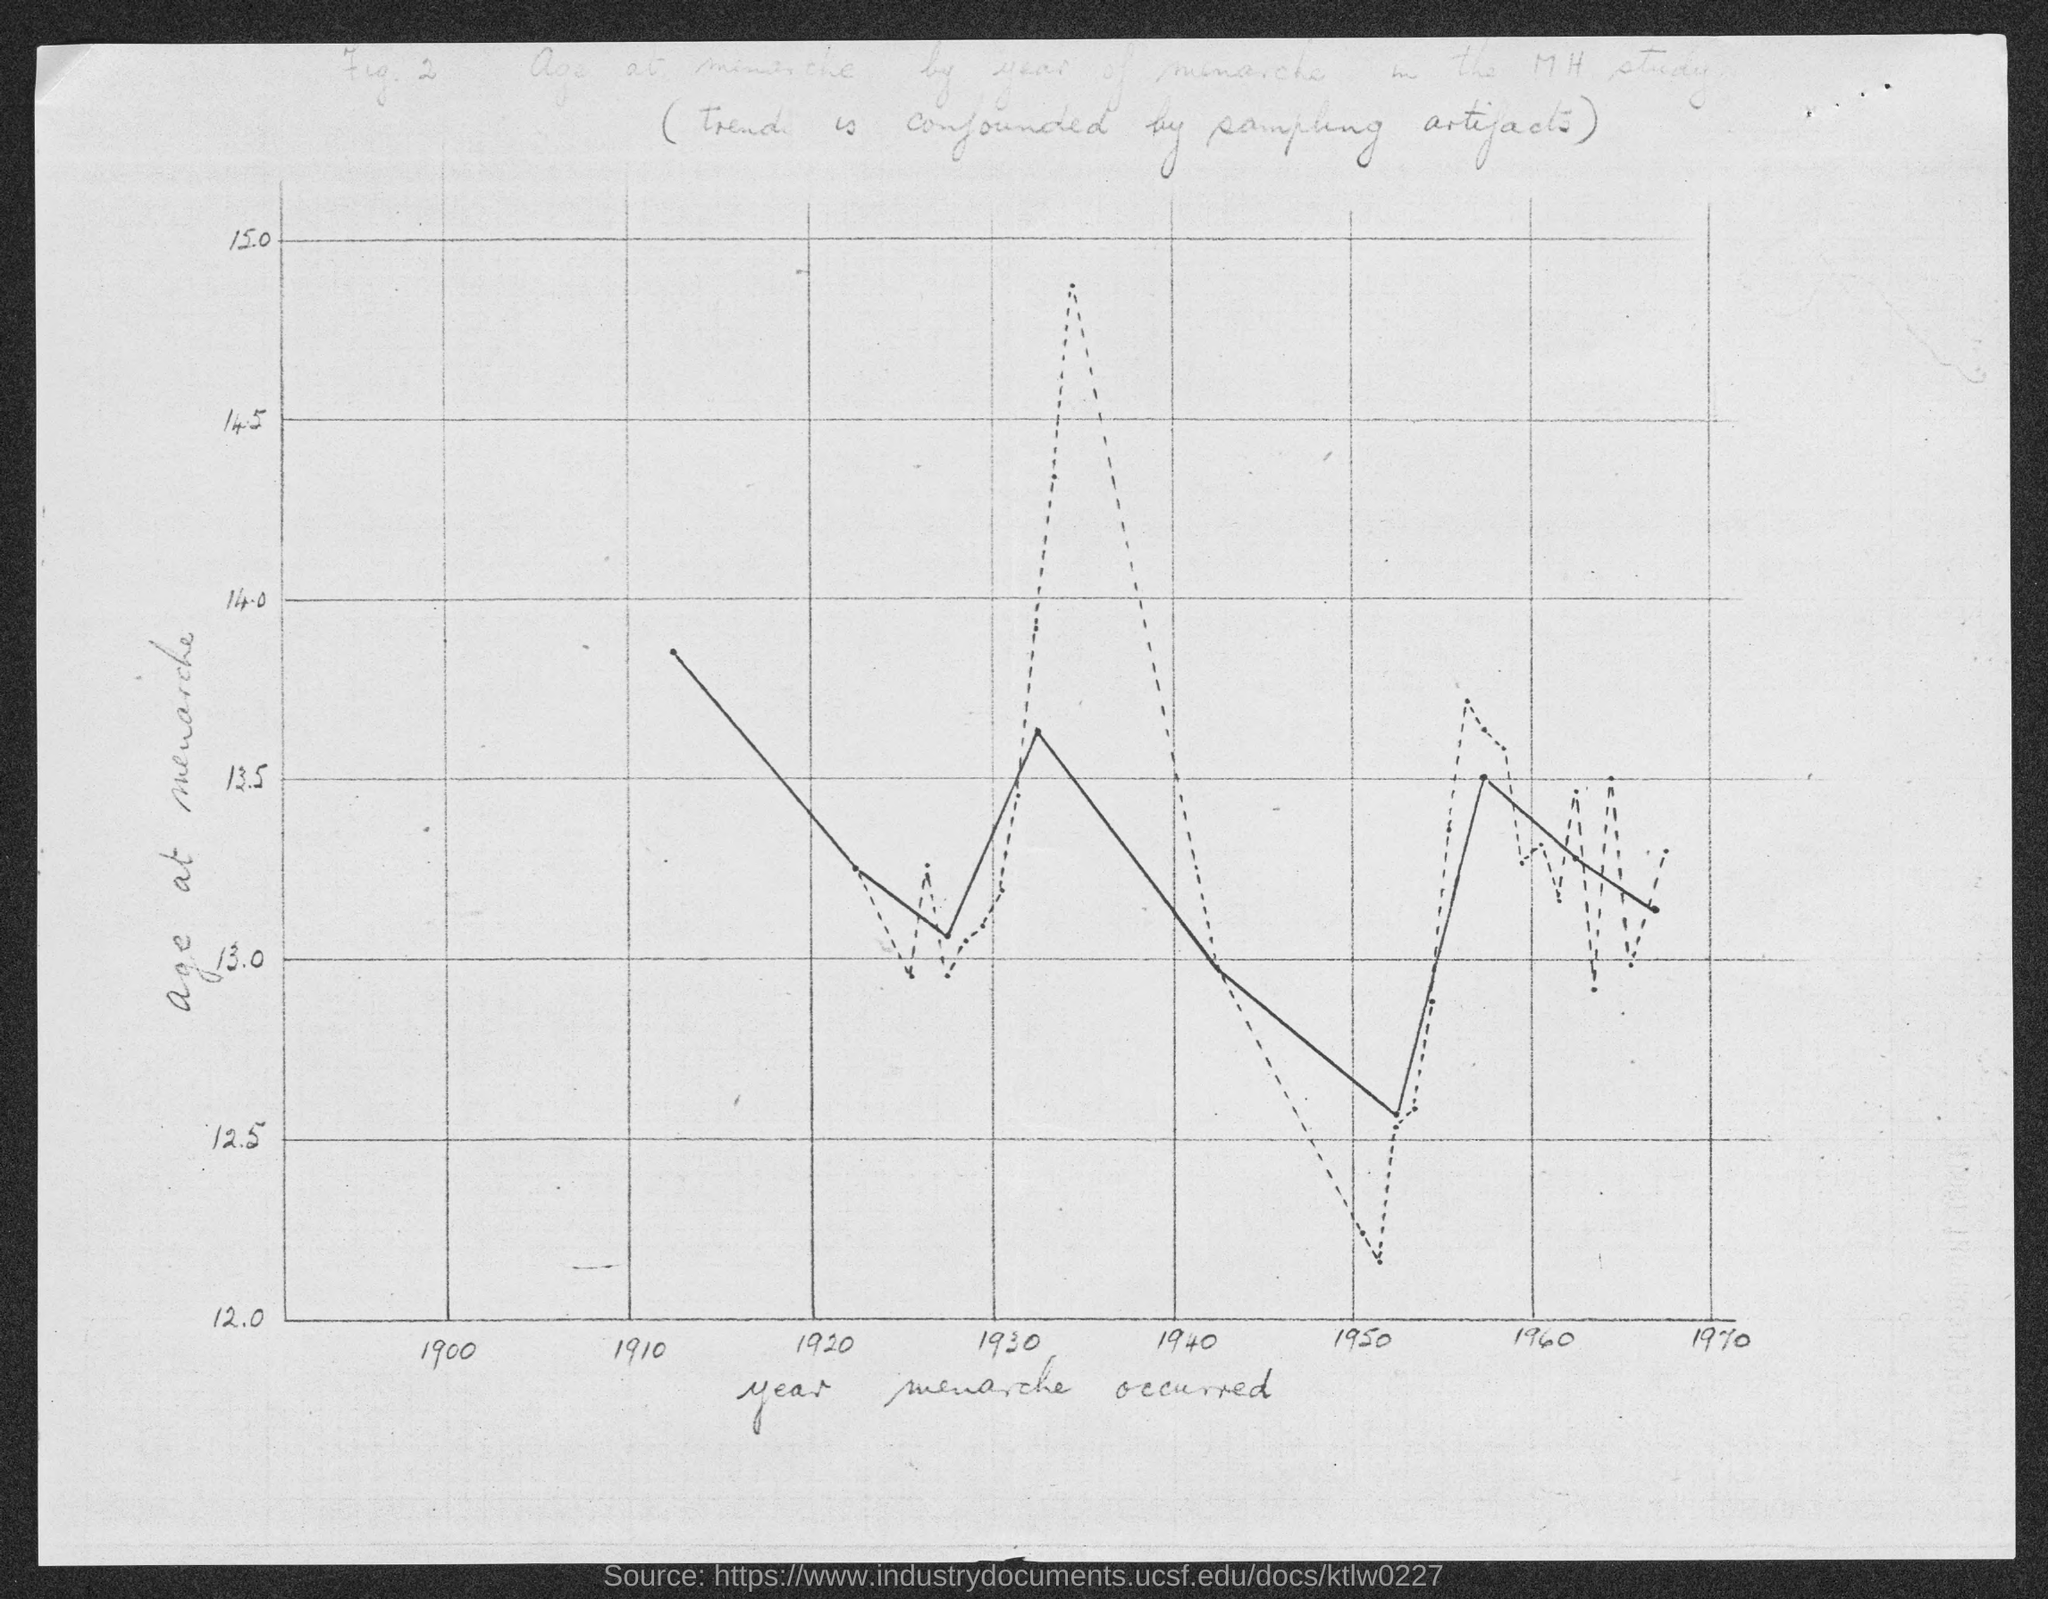Which year is mentioned first on x-axis?
Your answer should be compact. 1900. 